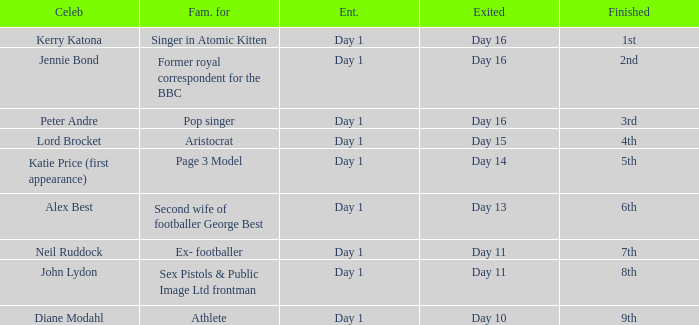Name the finished for kerry katona 1.0. 